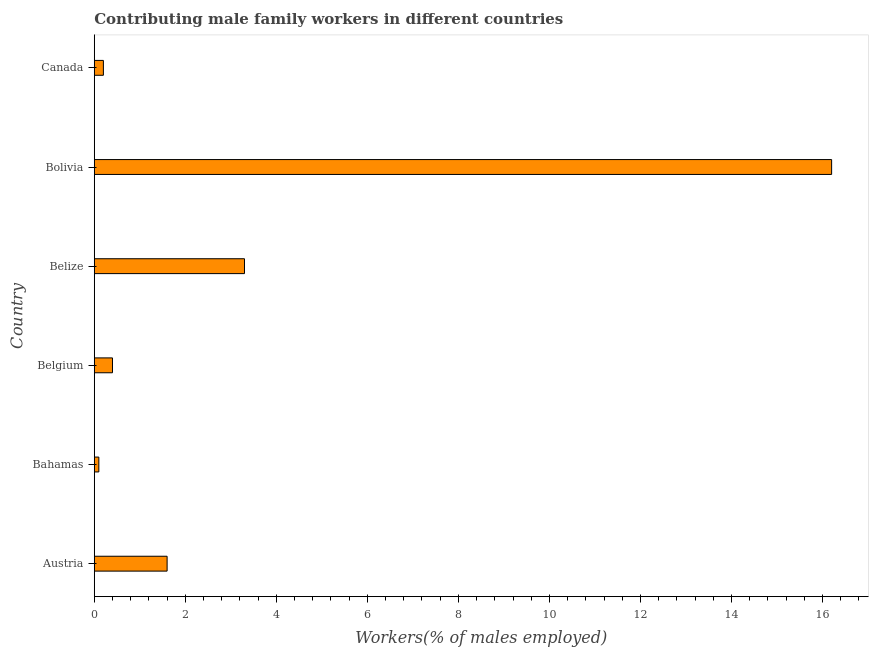What is the title of the graph?
Your answer should be very brief. Contributing male family workers in different countries. What is the label or title of the X-axis?
Keep it short and to the point. Workers(% of males employed). What is the label or title of the Y-axis?
Provide a succinct answer. Country. What is the contributing male family workers in Bahamas?
Keep it short and to the point. 0.1. Across all countries, what is the maximum contributing male family workers?
Provide a short and direct response. 16.2. Across all countries, what is the minimum contributing male family workers?
Your answer should be very brief. 0.1. In which country was the contributing male family workers minimum?
Offer a very short reply. Bahamas. What is the sum of the contributing male family workers?
Your response must be concise. 21.8. What is the difference between the contributing male family workers in Belize and Canada?
Keep it short and to the point. 3.1. What is the average contributing male family workers per country?
Give a very brief answer. 3.63. What is the median contributing male family workers?
Ensure brevity in your answer.  1. In how many countries, is the contributing male family workers greater than 4.4 %?
Your answer should be very brief. 1. What is the ratio of the contributing male family workers in Austria to that in Belize?
Your answer should be compact. 0.48. Is the difference between the contributing male family workers in Bahamas and Belgium greater than the difference between any two countries?
Offer a terse response. No. In how many countries, is the contributing male family workers greater than the average contributing male family workers taken over all countries?
Give a very brief answer. 1. How many countries are there in the graph?
Your response must be concise. 6. What is the difference between two consecutive major ticks on the X-axis?
Keep it short and to the point. 2. What is the Workers(% of males employed) in Austria?
Provide a short and direct response. 1.6. What is the Workers(% of males employed) of Bahamas?
Ensure brevity in your answer.  0.1. What is the Workers(% of males employed) of Belgium?
Offer a terse response. 0.4. What is the Workers(% of males employed) in Belize?
Provide a succinct answer. 3.3. What is the Workers(% of males employed) of Bolivia?
Your answer should be very brief. 16.2. What is the Workers(% of males employed) in Canada?
Give a very brief answer. 0.2. What is the difference between the Workers(% of males employed) in Austria and Bahamas?
Give a very brief answer. 1.5. What is the difference between the Workers(% of males employed) in Austria and Belgium?
Provide a short and direct response. 1.2. What is the difference between the Workers(% of males employed) in Austria and Bolivia?
Your answer should be compact. -14.6. What is the difference between the Workers(% of males employed) in Austria and Canada?
Your answer should be very brief. 1.4. What is the difference between the Workers(% of males employed) in Bahamas and Belize?
Offer a very short reply. -3.2. What is the difference between the Workers(% of males employed) in Bahamas and Bolivia?
Provide a succinct answer. -16.1. What is the difference between the Workers(% of males employed) in Bahamas and Canada?
Your answer should be compact. -0.1. What is the difference between the Workers(% of males employed) in Belgium and Belize?
Ensure brevity in your answer.  -2.9. What is the difference between the Workers(% of males employed) in Belgium and Bolivia?
Keep it short and to the point. -15.8. What is the difference between the Workers(% of males employed) in Belgium and Canada?
Give a very brief answer. 0.2. What is the difference between the Workers(% of males employed) in Belize and Bolivia?
Ensure brevity in your answer.  -12.9. What is the difference between the Workers(% of males employed) in Bolivia and Canada?
Provide a short and direct response. 16. What is the ratio of the Workers(% of males employed) in Austria to that in Bahamas?
Give a very brief answer. 16. What is the ratio of the Workers(% of males employed) in Austria to that in Belgium?
Ensure brevity in your answer.  4. What is the ratio of the Workers(% of males employed) in Austria to that in Belize?
Give a very brief answer. 0.48. What is the ratio of the Workers(% of males employed) in Austria to that in Bolivia?
Make the answer very short. 0.1. What is the ratio of the Workers(% of males employed) in Bahamas to that in Belize?
Provide a short and direct response. 0.03. What is the ratio of the Workers(% of males employed) in Bahamas to that in Bolivia?
Keep it short and to the point. 0.01. What is the ratio of the Workers(% of males employed) in Belgium to that in Belize?
Offer a very short reply. 0.12. What is the ratio of the Workers(% of males employed) in Belgium to that in Bolivia?
Make the answer very short. 0.03. What is the ratio of the Workers(% of males employed) in Belize to that in Bolivia?
Your response must be concise. 0.2. What is the ratio of the Workers(% of males employed) in Belize to that in Canada?
Your response must be concise. 16.5. What is the ratio of the Workers(% of males employed) in Bolivia to that in Canada?
Your response must be concise. 81. 